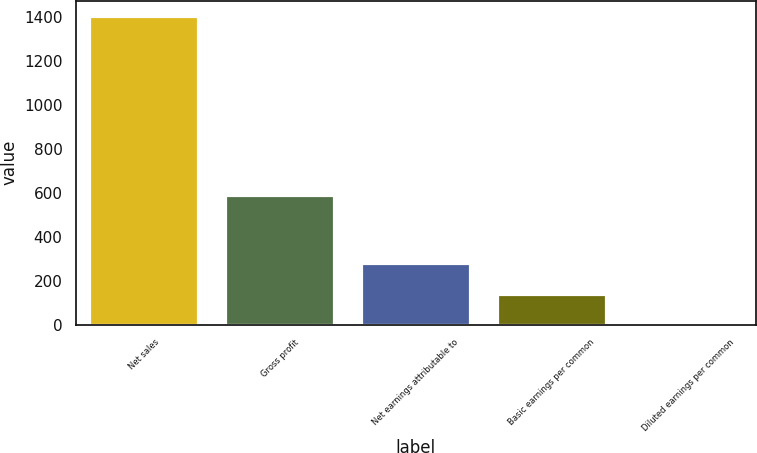Convert chart to OTSL. <chart><loc_0><loc_0><loc_500><loc_500><bar_chart><fcel>Net sales<fcel>Gross profit<fcel>Net earnings attributable to<fcel>Basic earnings per common<fcel>Diluted earnings per common<nl><fcel>1403.3<fcel>588.2<fcel>281.62<fcel>141.41<fcel>1.2<nl></chart> 